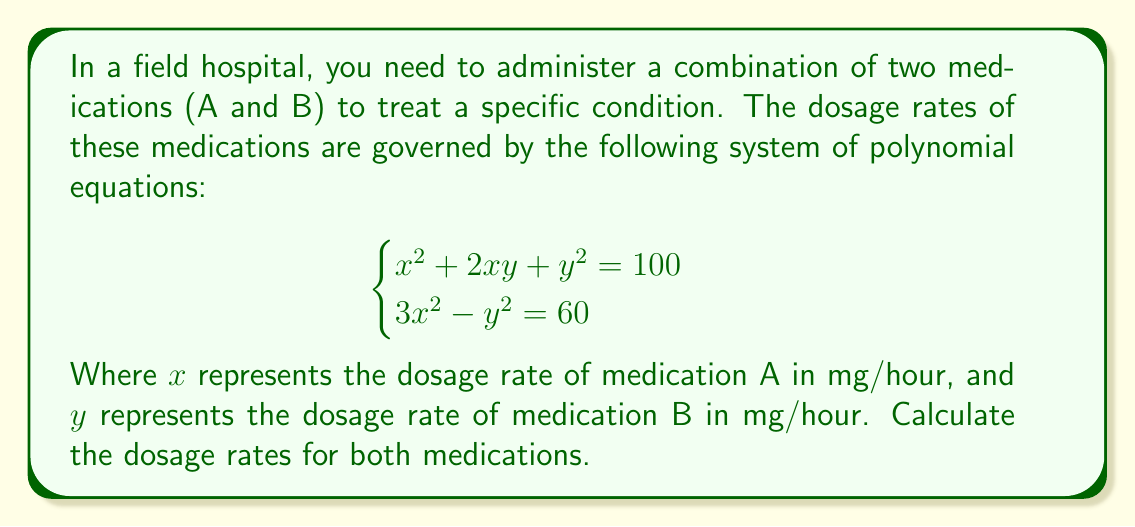Could you help me with this problem? Let's solve this system of equations step by step:

1) We have two equations:
   $$ \begin{cases}
   x^2 + 2xy + y^2 = 100 \quad (1) \\
   3x^2 - y^2 = 60 \quad (2)
   \end{cases} $$

2) From equation (2), we can express $y^2$ in terms of $x^2$:
   $$ y^2 = 3x^2 - 60 \quad (3) $$

3) Substitute (3) into equation (1):
   $$ x^2 + 2xy + (3x^2 - 60) = 100 $$
   $$ 4x^2 + 2xy - 160 = 0 \quad (4) $$

4) Divide equation (4) by $x$ (assuming $x \neq 0$):
   $$ 4x + 2y - \frac{160}{x} = 0 \quad (5) $$

5) Let $z = x + y$. Then $y = z - x$. Substitute this into (5):
   $$ 4x + 2(z-x) - \frac{160}{x} = 0 $$
   $$ 2x + 2z - \frac{160}{x} = 0 $$
   $$ 2x^2 + 2zx - 160 = 0 \quad (6) $$

6) From the definition of $z$ and equation (3):
   $$ z^2 = (x+y)^2 = x^2 + 2xy + y^2 = x^2 + 2xy + 3x^2 - 60 = 4x^2 + 2xy - 60 $$

7) Comparing this with equation (4), we see that $z^2 = 100$. So $z = 10$ (since $z > 0$ for positive dosages).

8) Substitute $z = 10$ into equation (6):
   $$ 2x^2 + 20x - 160 = 0 $$

9) Solve this quadratic equation:
   $$ x = \frac{-20 \pm \sqrt{400 + 1280}}{4} = \frac{-20 \pm \sqrt{1680}}{4} = \frac{-20 \pm 41}{4} $$

   The positive solution is $x = \frac{21}{4} = 5.25$

10) Since $z = x + y = 10$, we can find $y$:
    $$ y = 10 - 5.25 = 4.75 $$

Therefore, the dosage rate for medication A is 5.25 mg/hour, and for medication B is 4.75 mg/hour.
Answer: Medication A: 5.25 mg/hour, Medication B: 4.75 mg/hour 